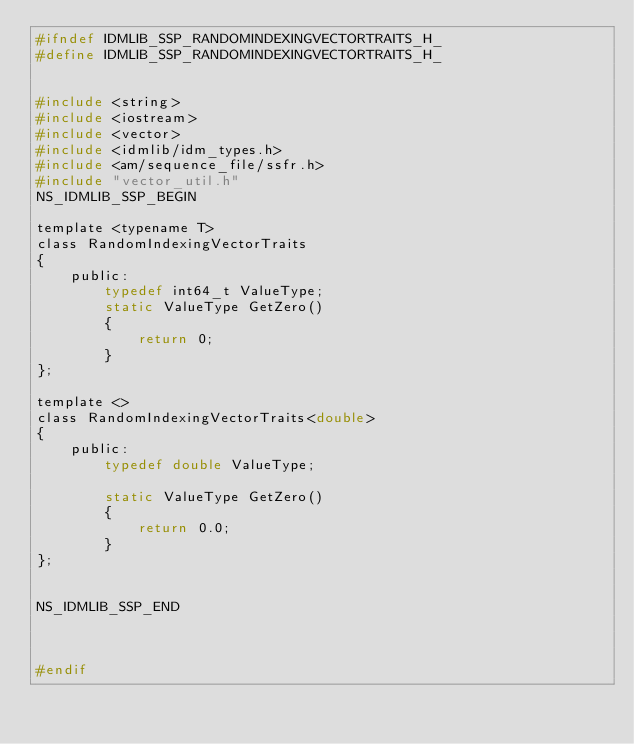<code> <loc_0><loc_0><loc_500><loc_500><_C_>#ifndef IDMLIB_SSP_RANDOMINDEXINGVECTORTRAITS_H_
#define IDMLIB_SSP_RANDOMINDEXINGVECTORTRAITS_H_


#include <string>
#include <iostream>
#include <vector>
#include <idmlib/idm_types.h>
#include <am/sequence_file/ssfr.h>
#include "vector_util.h"
NS_IDMLIB_SSP_BEGIN

template <typename T>
class RandomIndexingVectorTraits
{
    public:
        typedef int64_t ValueType;
        static ValueType GetZero()
        {
            return 0;
        }
};

template <>
class RandomIndexingVectorTraits<double>
{
    public:
        typedef double ValueType;
        
        static ValueType GetZero()
        {
            return 0.0;
        }
};

   
NS_IDMLIB_SSP_END



#endif 
</code> 